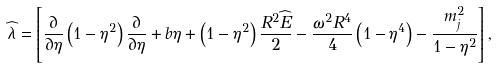<formula> <loc_0><loc_0><loc_500><loc_500>\widehat { \lambda } = \left [ \frac { \partial } { \partial \eta } \left ( 1 - \eta ^ { 2 } \right ) \frac { \partial } { \partial \eta } + b \eta + \left ( 1 - \eta ^ { 2 } \right ) \frac { R ^ { 2 } \widehat { E } } { 2 } - \frac { \omega ^ { 2 } R ^ { 4 } } { 4 } \left ( 1 - \eta ^ { 4 } \right ) - \frac { m _ { j } ^ { 2 } } { 1 - \eta ^ { 2 } } \right ] ,</formula> 